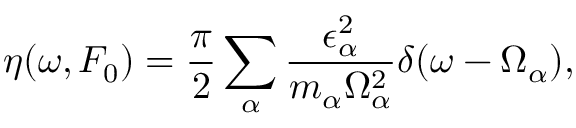<formula> <loc_0><loc_0><loc_500><loc_500>\eta ( \omega , F _ { 0 } ) = \frac { \pi } { 2 } \sum _ { \alpha } \frac { \epsilon _ { \alpha } ^ { 2 } } { m _ { \alpha } \Omega _ { \alpha } ^ { 2 } } \delta ( \omega - \Omega _ { \alpha } ) ,</formula> 